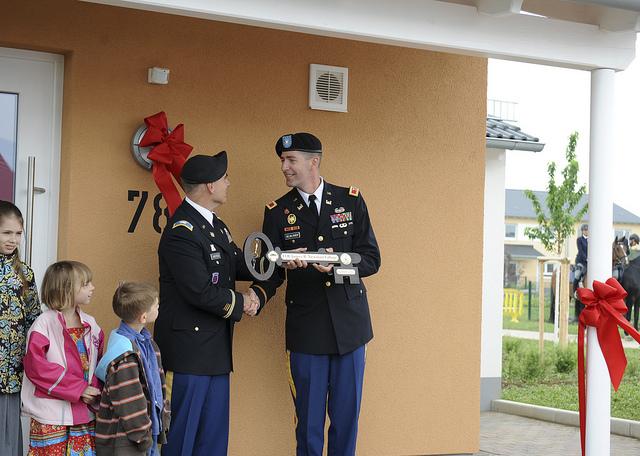Does the man on the right have high rank?
Keep it brief. Yes. Are the bows in the image?
Be succinct. Yes. Does the child look happy?
Concise answer only. Yes. What branch of the armed forces are these men in?
Concise answer only. Marines. What color is the girl's jacket?
Quick response, please. Pink. How many kids are there?
Give a very brief answer. 3. 